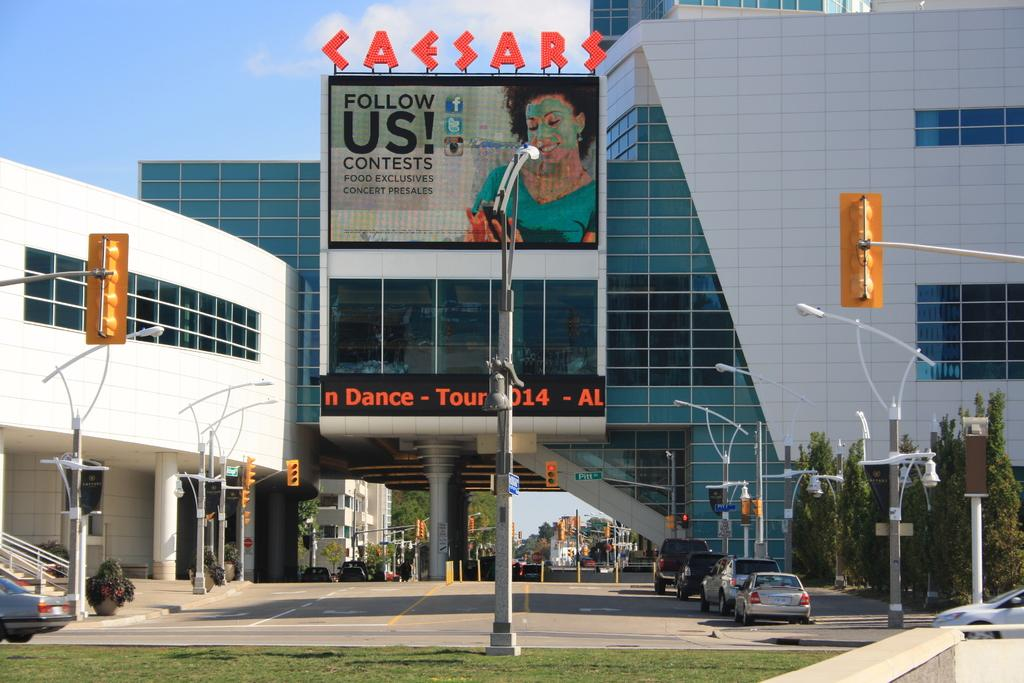What type of structures can be seen in the image? There are buildings in the image. What type of lighting is present in the image? There are street lamps in the image. What type of vegetation is present in the image? There is grass and trees in the image. What type of signage is present in the image? There is a banner in the image. What type of vehicles are present in the image? There are cars in the image. What celestial objects are visible in the image? There are stars visible in the image. What part of the natural environment is visible in the image? There is sky visible in the image. Can you see the toes of the people walking on the grass in the image? There are no people or toes visible in the image; it only shows buildings, street lamps, grass, trees, a banner, cars, stars, and sky. Is there a throne visible in the image? There is no throne present in the image. 